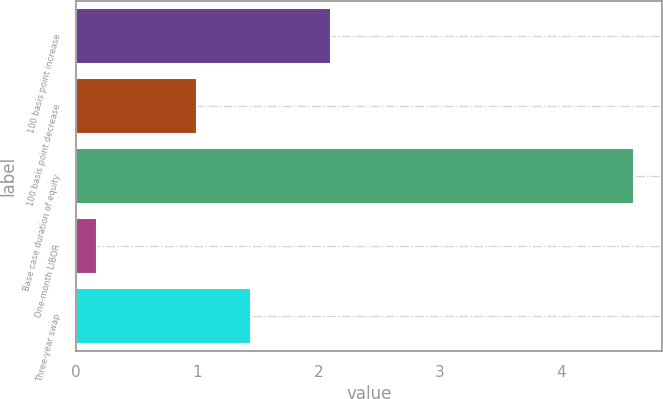Convert chart. <chart><loc_0><loc_0><loc_500><loc_500><bar_chart><fcel>100 basis point increase<fcel>100 basis point decrease<fcel>Base case duration of equity<fcel>One-month LIBOR<fcel>Three-year swap<nl><fcel>2.1<fcel>1<fcel>4.6<fcel>0.17<fcel>1.44<nl></chart> 